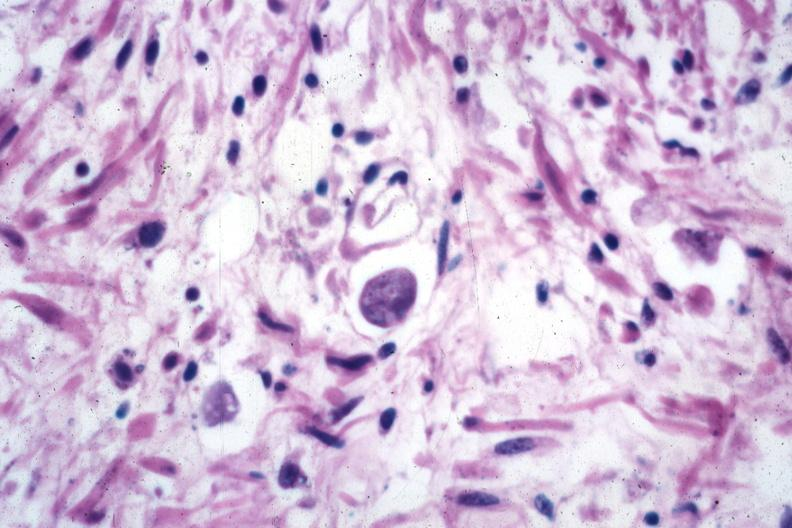s lymphangiomatosis present?
Answer the question using a single word or phrase. No 